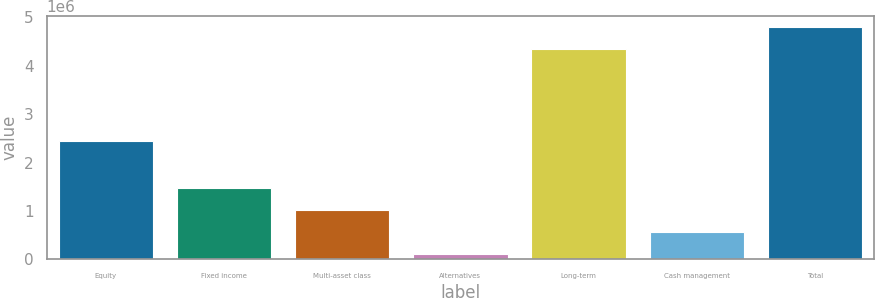<chart> <loc_0><loc_0><loc_500><loc_500><bar_chart><fcel>Equity<fcel>Fixed income<fcel>Multi-asset class<fcel>Alternatives<fcel>Long-term<fcel>Cash management<fcel>Total<nl><fcel>2.45111e+06<fcel>1.47344e+06<fcel>1.01937e+06<fcel>111240<fcel>4.33384e+06<fcel>565306<fcel>4.78791e+06<nl></chart> 